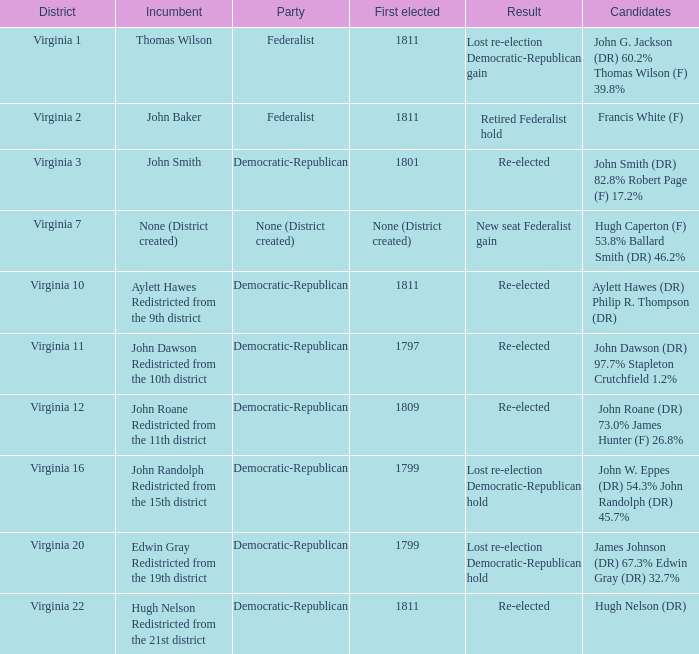Name the party for  john randolph redistricted from the 15th district Democratic-Republican. 